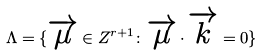Convert formula to latex. <formula><loc_0><loc_0><loc_500><loc_500>\Lambda = \{ \overrightarrow { \mu } \in Z ^ { r + 1 } \colon \overrightarrow { \mu } \cdot \overrightarrow { k } = 0 \}</formula> 